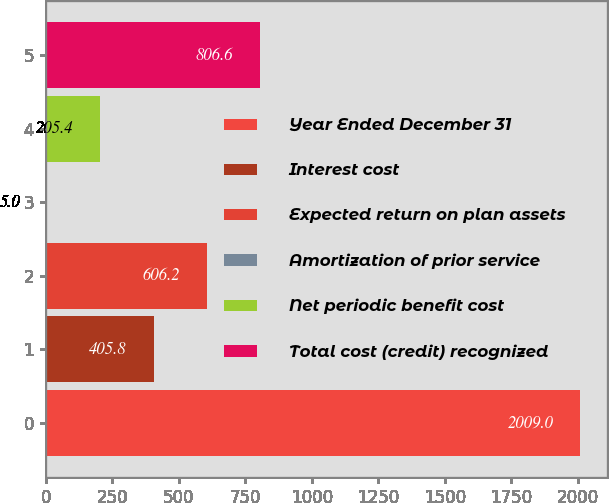Convert chart. <chart><loc_0><loc_0><loc_500><loc_500><bar_chart><fcel>Year Ended December 31<fcel>Interest cost<fcel>Expected return on plan assets<fcel>Amortization of prior service<fcel>Net periodic benefit cost<fcel>Total cost (credit) recognized<nl><fcel>2009<fcel>405.8<fcel>606.2<fcel>5<fcel>205.4<fcel>806.6<nl></chart> 